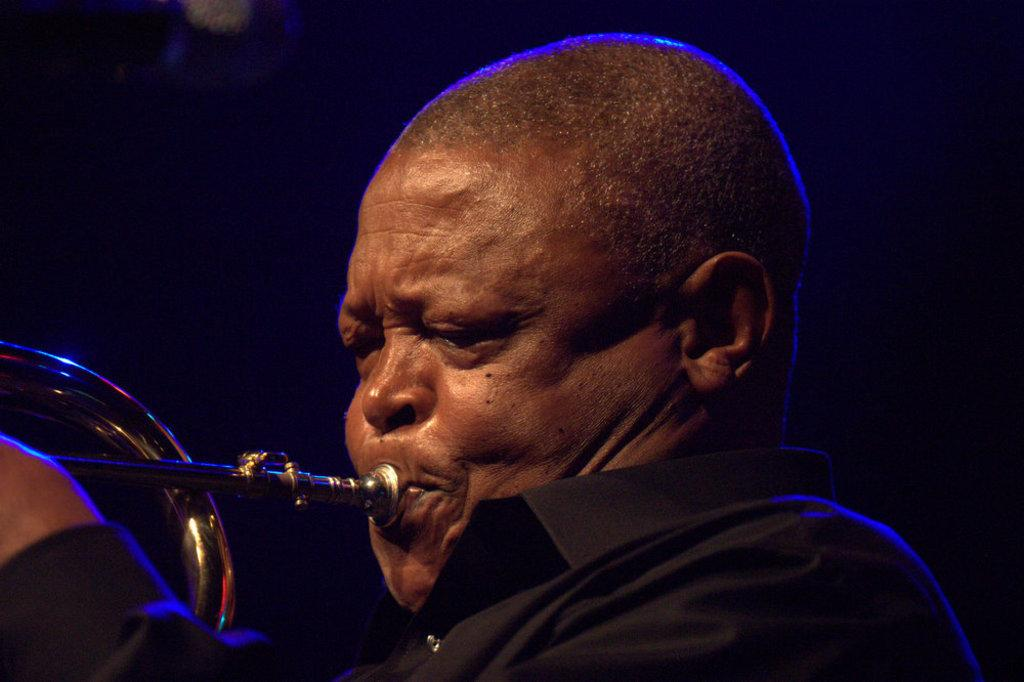What is the main subject of the image? There is a man in the image. What is the man wearing? The man is wearing a black shirt. What is the man doing in the image? The man is playing a musical instrument. In which direction is the man facing? The man is facing towards the left side. What is the color of the background in the image? The background of the image is black. What type of writer is sitting next to the man in the image? There is no writer present in the image; it only features a man playing a musical instrument. What kind of tail can be seen on the man's shirt in the image? The man's shirt is a black shirt without any visible tail. 